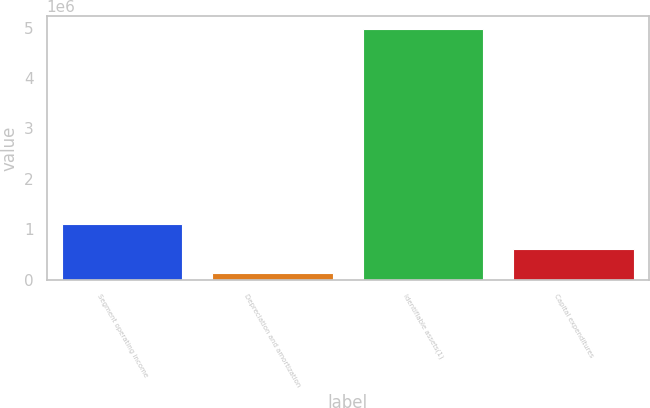Convert chart. <chart><loc_0><loc_0><loc_500><loc_500><bar_chart><fcel>Segment operating income<fcel>Depreciation and amortization<fcel>Identifiable assets(1)<fcel>Capital expenditures<nl><fcel>1.0978e+06<fcel>127087<fcel>4.98066e+06<fcel>612444<nl></chart> 